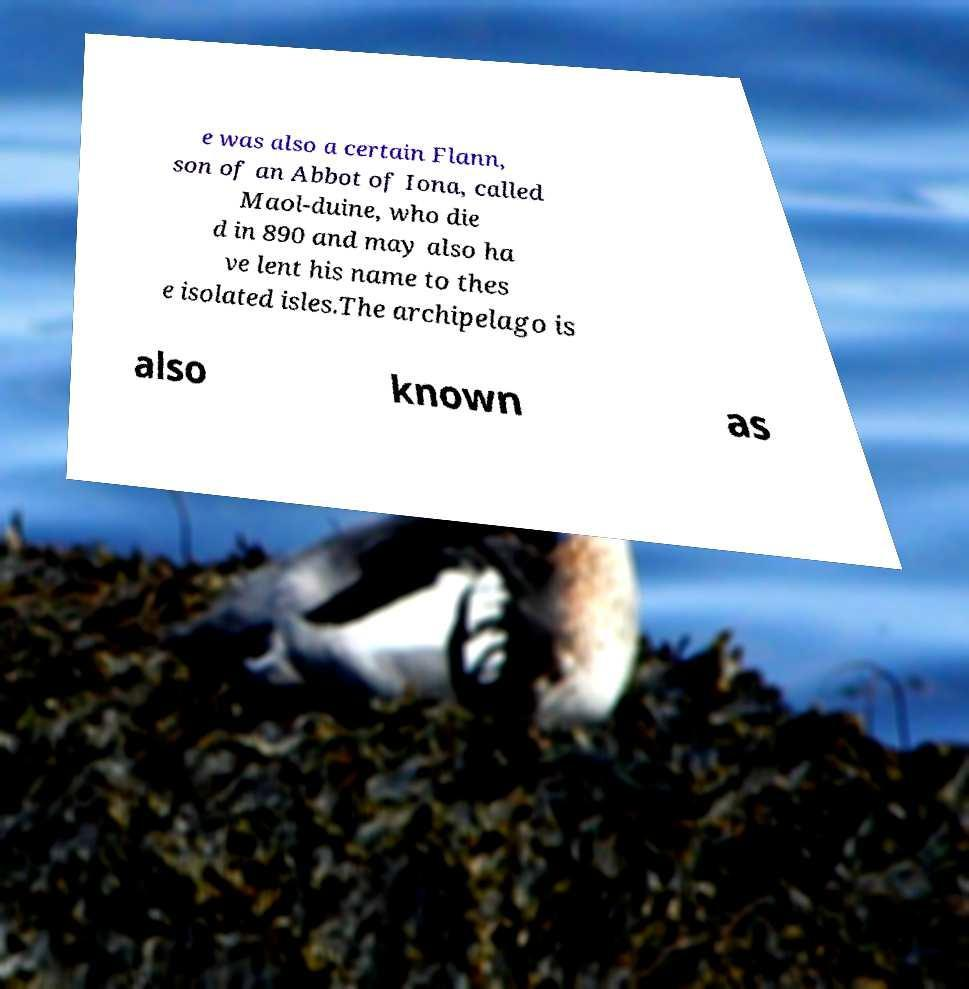Please read and relay the text visible in this image. What does it say? e was also a certain Flann, son of an Abbot of Iona, called Maol-duine, who die d in 890 and may also ha ve lent his name to thes e isolated isles.The archipelago is also known as 